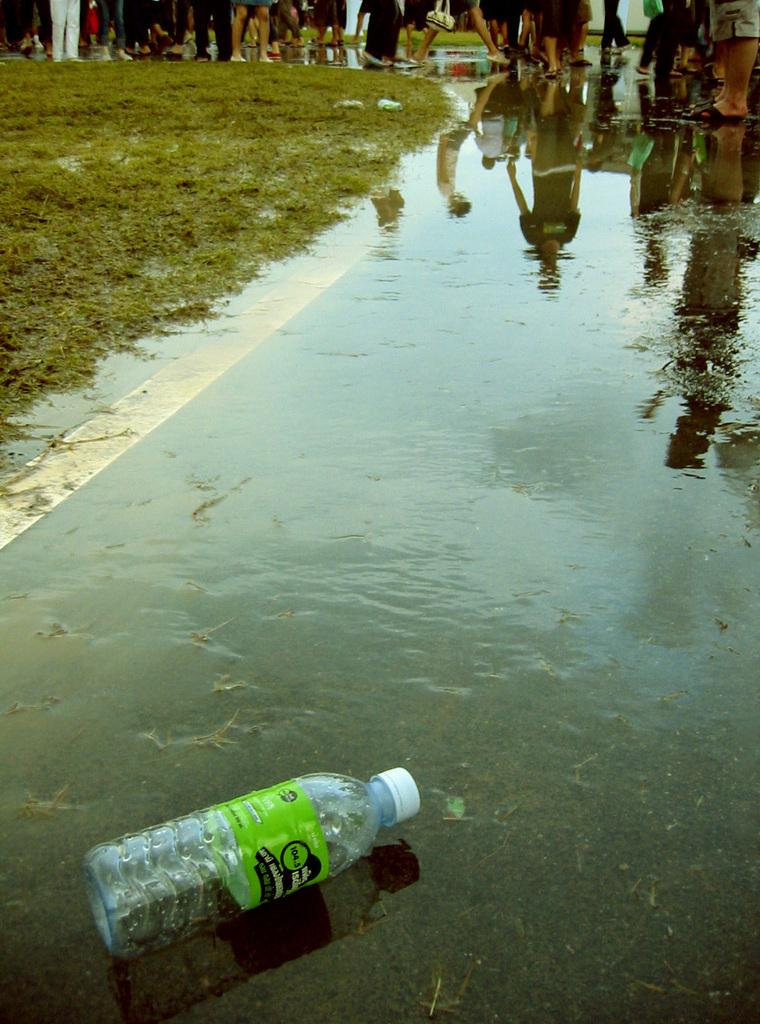What type of vegetation can be seen in the image? There is grass in the image. Can you describe the people in the image? There are people in the image. What else is visible besides the grass and people? There is water visible in the image. What object can be seen in the image that might be used for drinking? There is a bottle in the image. How many cactus can be seen in the image? There are no cactus present in the image. 